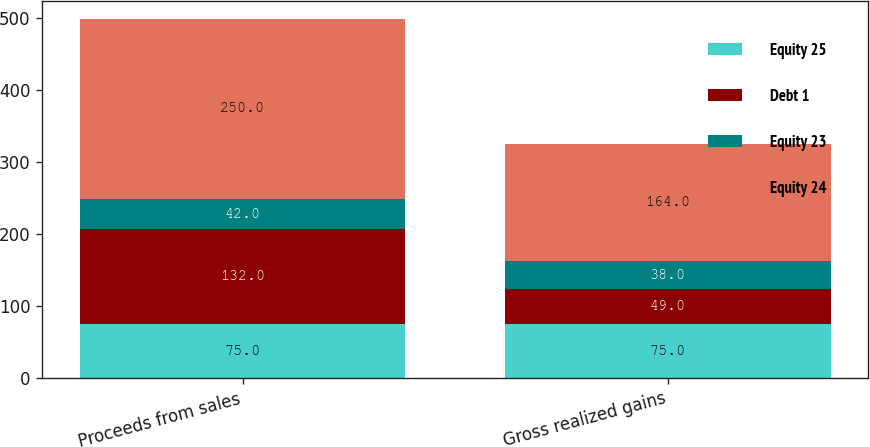Convert chart to OTSL. <chart><loc_0><loc_0><loc_500><loc_500><stacked_bar_chart><ecel><fcel>Proceeds from sales<fcel>Gross realized gains<nl><fcel>Equity 25<fcel>75<fcel>75<nl><fcel>Debt 1<fcel>132<fcel>49<nl><fcel>Equity 23<fcel>42<fcel>38<nl><fcel>Equity 24<fcel>250<fcel>164<nl></chart> 